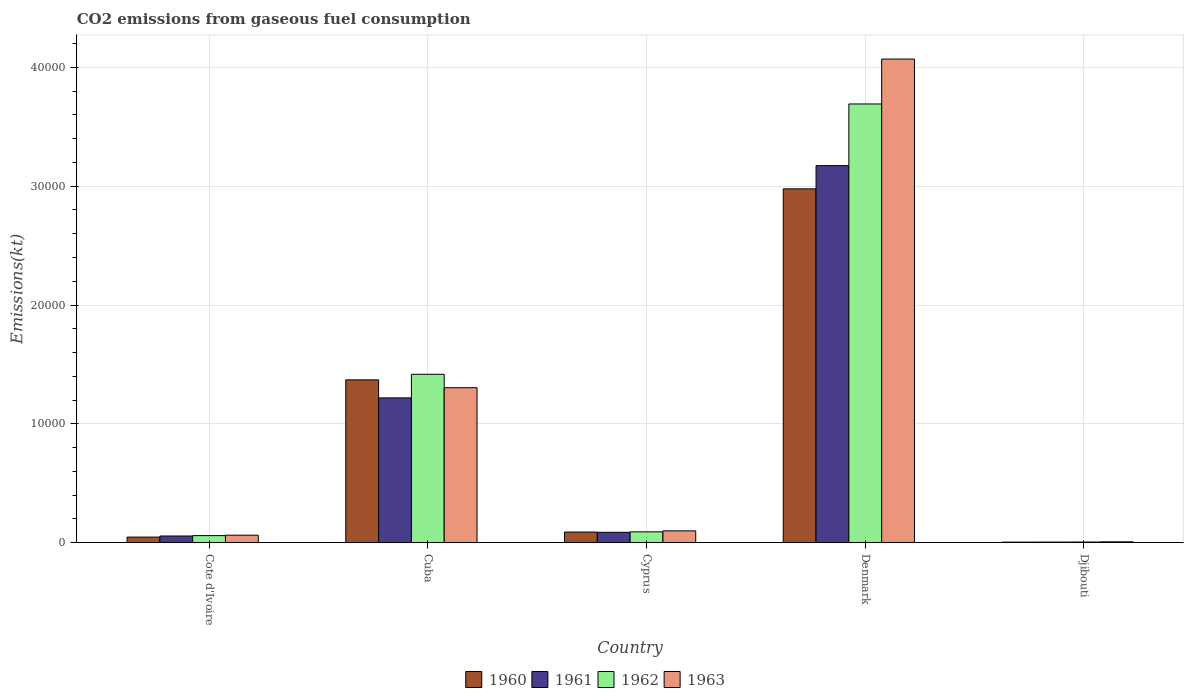How many bars are there on the 4th tick from the left?
Your answer should be compact. 4. What is the label of the 4th group of bars from the left?
Your answer should be very brief. Denmark. What is the amount of CO2 emitted in 1963 in Cote d'Ivoire?
Give a very brief answer. 623.39. Across all countries, what is the maximum amount of CO2 emitted in 1961?
Your answer should be very brief. 3.17e+04. Across all countries, what is the minimum amount of CO2 emitted in 1962?
Provide a short and direct response. 47.67. In which country was the amount of CO2 emitted in 1962 maximum?
Offer a very short reply. Denmark. In which country was the amount of CO2 emitted in 1963 minimum?
Give a very brief answer. Djibouti. What is the total amount of CO2 emitted in 1963 in the graph?
Offer a very short reply. 5.54e+04. What is the difference between the amount of CO2 emitted in 1961 in Cote d'Ivoire and that in Denmark?
Ensure brevity in your answer.  -3.12e+04. What is the difference between the amount of CO2 emitted in 1962 in Djibouti and the amount of CO2 emitted in 1963 in Denmark?
Provide a short and direct response. -4.07e+04. What is the average amount of CO2 emitted in 1961 per country?
Keep it short and to the point. 9075.83. What is the difference between the amount of CO2 emitted of/in 1963 and amount of CO2 emitted of/in 1961 in Denmark?
Provide a short and direct response. 8973.15. In how many countries, is the amount of CO2 emitted in 1962 greater than 28000 kt?
Make the answer very short. 1. What is the ratio of the amount of CO2 emitted in 1962 in Cuba to that in Cyprus?
Your response must be concise. 15.64. Is the amount of CO2 emitted in 1962 in Cuba less than that in Cyprus?
Keep it short and to the point. No. Is the difference between the amount of CO2 emitted in 1963 in Denmark and Djibouti greater than the difference between the amount of CO2 emitted in 1961 in Denmark and Djibouti?
Your answer should be compact. Yes. What is the difference between the highest and the second highest amount of CO2 emitted in 1960?
Provide a short and direct response. 1.61e+04. What is the difference between the highest and the lowest amount of CO2 emitted in 1961?
Offer a terse response. 3.17e+04. In how many countries, is the amount of CO2 emitted in 1962 greater than the average amount of CO2 emitted in 1962 taken over all countries?
Your response must be concise. 2. What does the 2nd bar from the left in Cyprus represents?
Keep it short and to the point. 1961. Is it the case that in every country, the sum of the amount of CO2 emitted in 1960 and amount of CO2 emitted in 1961 is greater than the amount of CO2 emitted in 1963?
Offer a very short reply. Yes. Does the graph contain any zero values?
Your response must be concise. No. Where does the legend appear in the graph?
Your answer should be very brief. Bottom center. How many legend labels are there?
Keep it short and to the point. 4. How are the legend labels stacked?
Provide a short and direct response. Horizontal. What is the title of the graph?
Offer a terse response. CO2 emissions from gaseous fuel consumption. What is the label or title of the Y-axis?
Offer a terse response. Emissions(kt). What is the Emissions(kt) of 1960 in Cote d'Ivoire?
Make the answer very short. 462.04. What is the Emissions(kt) of 1961 in Cote d'Ivoire?
Your response must be concise. 553.72. What is the Emissions(kt) of 1962 in Cote d'Ivoire?
Your answer should be very brief. 586.72. What is the Emissions(kt) in 1963 in Cote d'Ivoire?
Provide a succinct answer. 623.39. What is the Emissions(kt) of 1960 in Cuba?
Offer a terse response. 1.37e+04. What is the Emissions(kt) of 1961 in Cuba?
Provide a short and direct response. 1.22e+04. What is the Emissions(kt) of 1962 in Cuba?
Make the answer very short. 1.42e+04. What is the Emissions(kt) in 1963 in Cuba?
Your response must be concise. 1.30e+04. What is the Emissions(kt) in 1960 in Cyprus?
Make the answer very short. 887.41. What is the Emissions(kt) in 1961 in Cyprus?
Your answer should be very brief. 865.41. What is the Emissions(kt) in 1962 in Cyprus?
Your response must be concise. 905.75. What is the Emissions(kt) of 1963 in Cyprus?
Make the answer very short. 986.42. What is the Emissions(kt) of 1960 in Denmark?
Offer a very short reply. 2.98e+04. What is the Emissions(kt) in 1961 in Denmark?
Offer a terse response. 3.17e+04. What is the Emissions(kt) of 1962 in Denmark?
Your answer should be very brief. 3.69e+04. What is the Emissions(kt) of 1963 in Denmark?
Give a very brief answer. 4.07e+04. What is the Emissions(kt) in 1960 in Djibouti?
Offer a terse response. 40.34. What is the Emissions(kt) in 1961 in Djibouti?
Your answer should be compact. 44. What is the Emissions(kt) in 1962 in Djibouti?
Ensure brevity in your answer.  47.67. What is the Emissions(kt) of 1963 in Djibouti?
Your response must be concise. 66.01. Across all countries, what is the maximum Emissions(kt) in 1960?
Provide a short and direct response. 2.98e+04. Across all countries, what is the maximum Emissions(kt) of 1961?
Keep it short and to the point. 3.17e+04. Across all countries, what is the maximum Emissions(kt) in 1962?
Make the answer very short. 3.69e+04. Across all countries, what is the maximum Emissions(kt) of 1963?
Provide a succinct answer. 4.07e+04. Across all countries, what is the minimum Emissions(kt) in 1960?
Make the answer very short. 40.34. Across all countries, what is the minimum Emissions(kt) in 1961?
Offer a very short reply. 44. Across all countries, what is the minimum Emissions(kt) of 1962?
Provide a succinct answer. 47.67. Across all countries, what is the minimum Emissions(kt) in 1963?
Your answer should be compact. 66.01. What is the total Emissions(kt) of 1960 in the graph?
Your answer should be very brief. 4.49e+04. What is the total Emissions(kt) in 1961 in the graph?
Provide a short and direct response. 4.54e+04. What is the total Emissions(kt) of 1962 in the graph?
Make the answer very short. 5.26e+04. What is the total Emissions(kt) in 1963 in the graph?
Provide a short and direct response. 5.54e+04. What is the difference between the Emissions(kt) of 1960 in Cote d'Ivoire and that in Cuba?
Keep it short and to the point. -1.32e+04. What is the difference between the Emissions(kt) in 1961 in Cote d'Ivoire and that in Cuba?
Provide a succinct answer. -1.16e+04. What is the difference between the Emissions(kt) of 1962 in Cote d'Ivoire and that in Cuba?
Provide a succinct answer. -1.36e+04. What is the difference between the Emissions(kt) in 1963 in Cote d'Ivoire and that in Cuba?
Give a very brief answer. -1.24e+04. What is the difference between the Emissions(kt) in 1960 in Cote d'Ivoire and that in Cyprus?
Ensure brevity in your answer.  -425.37. What is the difference between the Emissions(kt) of 1961 in Cote d'Ivoire and that in Cyprus?
Keep it short and to the point. -311.69. What is the difference between the Emissions(kt) in 1962 in Cote d'Ivoire and that in Cyprus?
Offer a terse response. -319.03. What is the difference between the Emissions(kt) in 1963 in Cote d'Ivoire and that in Cyprus?
Your answer should be very brief. -363.03. What is the difference between the Emissions(kt) of 1960 in Cote d'Ivoire and that in Denmark?
Provide a succinct answer. -2.93e+04. What is the difference between the Emissions(kt) of 1961 in Cote d'Ivoire and that in Denmark?
Give a very brief answer. -3.12e+04. What is the difference between the Emissions(kt) of 1962 in Cote d'Ivoire and that in Denmark?
Ensure brevity in your answer.  -3.63e+04. What is the difference between the Emissions(kt) of 1963 in Cote d'Ivoire and that in Denmark?
Keep it short and to the point. -4.01e+04. What is the difference between the Emissions(kt) in 1960 in Cote d'Ivoire and that in Djibouti?
Your response must be concise. 421.7. What is the difference between the Emissions(kt) in 1961 in Cote d'Ivoire and that in Djibouti?
Offer a terse response. 509.71. What is the difference between the Emissions(kt) of 1962 in Cote d'Ivoire and that in Djibouti?
Provide a short and direct response. 539.05. What is the difference between the Emissions(kt) in 1963 in Cote d'Ivoire and that in Djibouti?
Keep it short and to the point. 557.38. What is the difference between the Emissions(kt) in 1960 in Cuba and that in Cyprus?
Your response must be concise. 1.28e+04. What is the difference between the Emissions(kt) in 1961 in Cuba and that in Cyprus?
Provide a short and direct response. 1.13e+04. What is the difference between the Emissions(kt) in 1962 in Cuba and that in Cyprus?
Keep it short and to the point. 1.33e+04. What is the difference between the Emissions(kt) of 1963 in Cuba and that in Cyprus?
Ensure brevity in your answer.  1.21e+04. What is the difference between the Emissions(kt) in 1960 in Cuba and that in Denmark?
Keep it short and to the point. -1.61e+04. What is the difference between the Emissions(kt) in 1961 in Cuba and that in Denmark?
Your answer should be compact. -1.96e+04. What is the difference between the Emissions(kt) of 1962 in Cuba and that in Denmark?
Your answer should be compact. -2.28e+04. What is the difference between the Emissions(kt) of 1963 in Cuba and that in Denmark?
Your answer should be very brief. -2.77e+04. What is the difference between the Emissions(kt) of 1960 in Cuba and that in Djibouti?
Your response must be concise. 1.37e+04. What is the difference between the Emissions(kt) of 1961 in Cuba and that in Djibouti?
Your response must be concise. 1.21e+04. What is the difference between the Emissions(kt) of 1962 in Cuba and that in Djibouti?
Keep it short and to the point. 1.41e+04. What is the difference between the Emissions(kt) in 1963 in Cuba and that in Djibouti?
Offer a terse response. 1.30e+04. What is the difference between the Emissions(kt) in 1960 in Cyprus and that in Denmark?
Offer a terse response. -2.89e+04. What is the difference between the Emissions(kt) of 1961 in Cyprus and that in Denmark?
Your answer should be very brief. -3.09e+04. What is the difference between the Emissions(kt) of 1962 in Cyprus and that in Denmark?
Provide a short and direct response. -3.60e+04. What is the difference between the Emissions(kt) in 1963 in Cyprus and that in Denmark?
Offer a terse response. -3.97e+04. What is the difference between the Emissions(kt) in 1960 in Cyprus and that in Djibouti?
Provide a succinct answer. 847.08. What is the difference between the Emissions(kt) in 1961 in Cyprus and that in Djibouti?
Your answer should be very brief. 821.41. What is the difference between the Emissions(kt) in 1962 in Cyprus and that in Djibouti?
Give a very brief answer. 858.08. What is the difference between the Emissions(kt) in 1963 in Cyprus and that in Djibouti?
Your answer should be compact. 920.42. What is the difference between the Emissions(kt) of 1960 in Denmark and that in Djibouti?
Make the answer very short. 2.97e+04. What is the difference between the Emissions(kt) of 1961 in Denmark and that in Djibouti?
Offer a terse response. 3.17e+04. What is the difference between the Emissions(kt) in 1962 in Denmark and that in Djibouti?
Provide a short and direct response. 3.69e+04. What is the difference between the Emissions(kt) in 1963 in Denmark and that in Djibouti?
Your answer should be very brief. 4.06e+04. What is the difference between the Emissions(kt) in 1960 in Cote d'Ivoire and the Emissions(kt) in 1961 in Cuba?
Provide a succinct answer. -1.17e+04. What is the difference between the Emissions(kt) of 1960 in Cote d'Ivoire and the Emissions(kt) of 1962 in Cuba?
Your response must be concise. -1.37e+04. What is the difference between the Emissions(kt) in 1960 in Cote d'Ivoire and the Emissions(kt) in 1963 in Cuba?
Your answer should be very brief. -1.26e+04. What is the difference between the Emissions(kt) in 1961 in Cote d'Ivoire and the Emissions(kt) in 1962 in Cuba?
Your response must be concise. -1.36e+04. What is the difference between the Emissions(kt) in 1961 in Cote d'Ivoire and the Emissions(kt) in 1963 in Cuba?
Keep it short and to the point. -1.25e+04. What is the difference between the Emissions(kt) in 1962 in Cote d'Ivoire and the Emissions(kt) in 1963 in Cuba?
Provide a succinct answer. -1.25e+04. What is the difference between the Emissions(kt) of 1960 in Cote d'Ivoire and the Emissions(kt) of 1961 in Cyprus?
Your answer should be very brief. -403.37. What is the difference between the Emissions(kt) of 1960 in Cote d'Ivoire and the Emissions(kt) of 1962 in Cyprus?
Keep it short and to the point. -443.71. What is the difference between the Emissions(kt) of 1960 in Cote d'Ivoire and the Emissions(kt) of 1963 in Cyprus?
Offer a very short reply. -524.38. What is the difference between the Emissions(kt) in 1961 in Cote d'Ivoire and the Emissions(kt) in 1962 in Cyprus?
Make the answer very short. -352.03. What is the difference between the Emissions(kt) in 1961 in Cote d'Ivoire and the Emissions(kt) in 1963 in Cyprus?
Provide a short and direct response. -432.71. What is the difference between the Emissions(kt) in 1962 in Cote d'Ivoire and the Emissions(kt) in 1963 in Cyprus?
Provide a succinct answer. -399.7. What is the difference between the Emissions(kt) in 1960 in Cote d'Ivoire and the Emissions(kt) in 1961 in Denmark?
Make the answer very short. -3.13e+04. What is the difference between the Emissions(kt) of 1960 in Cote d'Ivoire and the Emissions(kt) of 1962 in Denmark?
Make the answer very short. -3.65e+04. What is the difference between the Emissions(kt) in 1960 in Cote d'Ivoire and the Emissions(kt) in 1963 in Denmark?
Offer a very short reply. -4.02e+04. What is the difference between the Emissions(kt) of 1961 in Cote d'Ivoire and the Emissions(kt) of 1962 in Denmark?
Give a very brief answer. -3.64e+04. What is the difference between the Emissions(kt) of 1961 in Cote d'Ivoire and the Emissions(kt) of 1963 in Denmark?
Ensure brevity in your answer.  -4.02e+04. What is the difference between the Emissions(kt) in 1962 in Cote d'Ivoire and the Emissions(kt) in 1963 in Denmark?
Your response must be concise. -4.01e+04. What is the difference between the Emissions(kt) of 1960 in Cote d'Ivoire and the Emissions(kt) of 1961 in Djibouti?
Your answer should be very brief. 418.04. What is the difference between the Emissions(kt) in 1960 in Cote d'Ivoire and the Emissions(kt) in 1962 in Djibouti?
Your response must be concise. 414.37. What is the difference between the Emissions(kt) of 1960 in Cote d'Ivoire and the Emissions(kt) of 1963 in Djibouti?
Provide a short and direct response. 396.04. What is the difference between the Emissions(kt) of 1961 in Cote d'Ivoire and the Emissions(kt) of 1962 in Djibouti?
Keep it short and to the point. 506.05. What is the difference between the Emissions(kt) in 1961 in Cote d'Ivoire and the Emissions(kt) in 1963 in Djibouti?
Provide a succinct answer. 487.71. What is the difference between the Emissions(kt) of 1962 in Cote d'Ivoire and the Emissions(kt) of 1963 in Djibouti?
Your answer should be very brief. 520.71. What is the difference between the Emissions(kt) of 1960 in Cuba and the Emissions(kt) of 1961 in Cyprus?
Offer a terse response. 1.28e+04. What is the difference between the Emissions(kt) of 1960 in Cuba and the Emissions(kt) of 1962 in Cyprus?
Offer a terse response. 1.28e+04. What is the difference between the Emissions(kt) in 1960 in Cuba and the Emissions(kt) in 1963 in Cyprus?
Provide a short and direct response. 1.27e+04. What is the difference between the Emissions(kt) in 1961 in Cuba and the Emissions(kt) in 1962 in Cyprus?
Ensure brevity in your answer.  1.13e+04. What is the difference between the Emissions(kt) of 1961 in Cuba and the Emissions(kt) of 1963 in Cyprus?
Keep it short and to the point. 1.12e+04. What is the difference between the Emissions(kt) of 1962 in Cuba and the Emissions(kt) of 1963 in Cyprus?
Offer a very short reply. 1.32e+04. What is the difference between the Emissions(kt) of 1960 in Cuba and the Emissions(kt) of 1961 in Denmark?
Provide a succinct answer. -1.80e+04. What is the difference between the Emissions(kt) of 1960 in Cuba and the Emissions(kt) of 1962 in Denmark?
Offer a very short reply. -2.32e+04. What is the difference between the Emissions(kt) of 1960 in Cuba and the Emissions(kt) of 1963 in Denmark?
Ensure brevity in your answer.  -2.70e+04. What is the difference between the Emissions(kt) of 1961 in Cuba and the Emissions(kt) of 1962 in Denmark?
Provide a short and direct response. -2.47e+04. What is the difference between the Emissions(kt) in 1961 in Cuba and the Emissions(kt) in 1963 in Denmark?
Ensure brevity in your answer.  -2.85e+04. What is the difference between the Emissions(kt) of 1962 in Cuba and the Emissions(kt) of 1963 in Denmark?
Your response must be concise. -2.65e+04. What is the difference between the Emissions(kt) of 1960 in Cuba and the Emissions(kt) of 1961 in Djibouti?
Your response must be concise. 1.37e+04. What is the difference between the Emissions(kt) of 1960 in Cuba and the Emissions(kt) of 1962 in Djibouti?
Offer a very short reply. 1.37e+04. What is the difference between the Emissions(kt) of 1960 in Cuba and the Emissions(kt) of 1963 in Djibouti?
Ensure brevity in your answer.  1.36e+04. What is the difference between the Emissions(kt) in 1961 in Cuba and the Emissions(kt) in 1962 in Djibouti?
Offer a terse response. 1.21e+04. What is the difference between the Emissions(kt) of 1961 in Cuba and the Emissions(kt) of 1963 in Djibouti?
Offer a terse response. 1.21e+04. What is the difference between the Emissions(kt) in 1962 in Cuba and the Emissions(kt) in 1963 in Djibouti?
Offer a terse response. 1.41e+04. What is the difference between the Emissions(kt) of 1960 in Cyprus and the Emissions(kt) of 1961 in Denmark?
Ensure brevity in your answer.  -3.08e+04. What is the difference between the Emissions(kt) in 1960 in Cyprus and the Emissions(kt) in 1962 in Denmark?
Provide a succinct answer. -3.60e+04. What is the difference between the Emissions(kt) in 1960 in Cyprus and the Emissions(kt) in 1963 in Denmark?
Give a very brief answer. -3.98e+04. What is the difference between the Emissions(kt) of 1961 in Cyprus and the Emissions(kt) of 1962 in Denmark?
Ensure brevity in your answer.  -3.61e+04. What is the difference between the Emissions(kt) of 1961 in Cyprus and the Emissions(kt) of 1963 in Denmark?
Ensure brevity in your answer.  -3.98e+04. What is the difference between the Emissions(kt) of 1962 in Cyprus and the Emissions(kt) of 1963 in Denmark?
Keep it short and to the point. -3.98e+04. What is the difference between the Emissions(kt) in 1960 in Cyprus and the Emissions(kt) in 1961 in Djibouti?
Your answer should be compact. 843.41. What is the difference between the Emissions(kt) in 1960 in Cyprus and the Emissions(kt) in 1962 in Djibouti?
Offer a terse response. 839.74. What is the difference between the Emissions(kt) of 1960 in Cyprus and the Emissions(kt) of 1963 in Djibouti?
Your response must be concise. 821.41. What is the difference between the Emissions(kt) of 1961 in Cyprus and the Emissions(kt) of 1962 in Djibouti?
Keep it short and to the point. 817.74. What is the difference between the Emissions(kt) of 1961 in Cyprus and the Emissions(kt) of 1963 in Djibouti?
Offer a terse response. 799.41. What is the difference between the Emissions(kt) of 1962 in Cyprus and the Emissions(kt) of 1963 in Djibouti?
Provide a short and direct response. 839.74. What is the difference between the Emissions(kt) in 1960 in Denmark and the Emissions(kt) in 1961 in Djibouti?
Keep it short and to the point. 2.97e+04. What is the difference between the Emissions(kt) of 1960 in Denmark and the Emissions(kt) of 1962 in Djibouti?
Your answer should be compact. 2.97e+04. What is the difference between the Emissions(kt) in 1960 in Denmark and the Emissions(kt) in 1963 in Djibouti?
Keep it short and to the point. 2.97e+04. What is the difference between the Emissions(kt) of 1961 in Denmark and the Emissions(kt) of 1962 in Djibouti?
Ensure brevity in your answer.  3.17e+04. What is the difference between the Emissions(kt) in 1961 in Denmark and the Emissions(kt) in 1963 in Djibouti?
Offer a terse response. 3.17e+04. What is the difference between the Emissions(kt) in 1962 in Denmark and the Emissions(kt) in 1963 in Djibouti?
Offer a very short reply. 3.69e+04. What is the average Emissions(kt) in 1960 per country?
Offer a terse response. 8973.88. What is the average Emissions(kt) of 1961 per country?
Your answer should be compact. 9075.83. What is the average Emissions(kt) of 1962 per country?
Your answer should be compact. 1.05e+04. What is the average Emissions(kt) of 1963 per country?
Offer a terse response. 1.11e+04. What is the difference between the Emissions(kt) of 1960 and Emissions(kt) of 1961 in Cote d'Ivoire?
Offer a very short reply. -91.67. What is the difference between the Emissions(kt) in 1960 and Emissions(kt) in 1962 in Cote d'Ivoire?
Give a very brief answer. -124.68. What is the difference between the Emissions(kt) in 1960 and Emissions(kt) in 1963 in Cote d'Ivoire?
Your response must be concise. -161.35. What is the difference between the Emissions(kt) in 1961 and Emissions(kt) in 1962 in Cote d'Ivoire?
Provide a succinct answer. -33. What is the difference between the Emissions(kt) of 1961 and Emissions(kt) of 1963 in Cote d'Ivoire?
Your answer should be very brief. -69.67. What is the difference between the Emissions(kt) in 1962 and Emissions(kt) in 1963 in Cote d'Ivoire?
Provide a short and direct response. -36.67. What is the difference between the Emissions(kt) in 1960 and Emissions(kt) in 1961 in Cuba?
Provide a succinct answer. 1518.14. What is the difference between the Emissions(kt) of 1960 and Emissions(kt) of 1962 in Cuba?
Your response must be concise. -469.38. What is the difference between the Emissions(kt) of 1960 and Emissions(kt) of 1963 in Cuba?
Your answer should be very brief. 660.06. What is the difference between the Emissions(kt) in 1961 and Emissions(kt) in 1962 in Cuba?
Provide a succinct answer. -1987.51. What is the difference between the Emissions(kt) of 1961 and Emissions(kt) of 1963 in Cuba?
Make the answer very short. -858.08. What is the difference between the Emissions(kt) of 1962 and Emissions(kt) of 1963 in Cuba?
Ensure brevity in your answer.  1129.44. What is the difference between the Emissions(kt) in 1960 and Emissions(kt) in 1961 in Cyprus?
Make the answer very short. 22. What is the difference between the Emissions(kt) in 1960 and Emissions(kt) in 1962 in Cyprus?
Offer a very short reply. -18.34. What is the difference between the Emissions(kt) of 1960 and Emissions(kt) of 1963 in Cyprus?
Your answer should be very brief. -99.01. What is the difference between the Emissions(kt) in 1961 and Emissions(kt) in 1962 in Cyprus?
Your answer should be very brief. -40.34. What is the difference between the Emissions(kt) of 1961 and Emissions(kt) of 1963 in Cyprus?
Your response must be concise. -121.01. What is the difference between the Emissions(kt) of 1962 and Emissions(kt) of 1963 in Cyprus?
Your answer should be compact. -80.67. What is the difference between the Emissions(kt) of 1960 and Emissions(kt) of 1961 in Denmark?
Your response must be concise. -1954.51. What is the difference between the Emissions(kt) in 1960 and Emissions(kt) in 1962 in Denmark?
Your response must be concise. -7146.98. What is the difference between the Emissions(kt) of 1960 and Emissions(kt) of 1963 in Denmark?
Ensure brevity in your answer.  -1.09e+04. What is the difference between the Emissions(kt) of 1961 and Emissions(kt) of 1962 in Denmark?
Provide a short and direct response. -5192.47. What is the difference between the Emissions(kt) of 1961 and Emissions(kt) of 1963 in Denmark?
Give a very brief answer. -8973.15. What is the difference between the Emissions(kt) in 1962 and Emissions(kt) in 1963 in Denmark?
Keep it short and to the point. -3780.68. What is the difference between the Emissions(kt) in 1960 and Emissions(kt) in 1961 in Djibouti?
Your answer should be compact. -3.67. What is the difference between the Emissions(kt) of 1960 and Emissions(kt) of 1962 in Djibouti?
Provide a succinct answer. -7.33. What is the difference between the Emissions(kt) in 1960 and Emissions(kt) in 1963 in Djibouti?
Provide a short and direct response. -25.67. What is the difference between the Emissions(kt) in 1961 and Emissions(kt) in 1962 in Djibouti?
Your answer should be very brief. -3.67. What is the difference between the Emissions(kt) in 1961 and Emissions(kt) in 1963 in Djibouti?
Your answer should be very brief. -22. What is the difference between the Emissions(kt) of 1962 and Emissions(kt) of 1963 in Djibouti?
Give a very brief answer. -18.34. What is the ratio of the Emissions(kt) of 1960 in Cote d'Ivoire to that in Cuba?
Keep it short and to the point. 0.03. What is the ratio of the Emissions(kt) in 1961 in Cote d'Ivoire to that in Cuba?
Your response must be concise. 0.05. What is the ratio of the Emissions(kt) in 1962 in Cote d'Ivoire to that in Cuba?
Ensure brevity in your answer.  0.04. What is the ratio of the Emissions(kt) of 1963 in Cote d'Ivoire to that in Cuba?
Provide a short and direct response. 0.05. What is the ratio of the Emissions(kt) in 1960 in Cote d'Ivoire to that in Cyprus?
Your answer should be very brief. 0.52. What is the ratio of the Emissions(kt) in 1961 in Cote d'Ivoire to that in Cyprus?
Make the answer very short. 0.64. What is the ratio of the Emissions(kt) in 1962 in Cote d'Ivoire to that in Cyprus?
Make the answer very short. 0.65. What is the ratio of the Emissions(kt) of 1963 in Cote d'Ivoire to that in Cyprus?
Your answer should be compact. 0.63. What is the ratio of the Emissions(kt) of 1960 in Cote d'Ivoire to that in Denmark?
Your response must be concise. 0.02. What is the ratio of the Emissions(kt) in 1961 in Cote d'Ivoire to that in Denmark?
Ensure brevity in your answer.  0.02. What is the ratio of the Emissions(kt) of 1962 in Cote d'Ivoire to that in Denmark?
Keep it short and to the point. 0.02. What is the ratio of the Emissions(kt) of 1963 in Cote d'Ivoire to that in Denmark?
Provide a short and direct response. 0.02. What is the ratio of the Emissions(kt) in 1960 in Cote d'Ivoire to that in Djibouti?
Your answer should be compact. 11.45. What is the ratio of the Emissions(kt) in 1961 in Cote d'Ivoire to that in Djibouti?
Keep it short and to the point. 12.58. What is the ratio of the Emissions(kt) of 1962 in Cote d'Ivoire to that in Djibouti?
Offer a very short reply. 12.31. What is the ratio of the Emissions(kt) in 1963 in Cote d'Ivoire to that in Djibouti?
Provide a short and direct response. 9.44. What is the ratio of the Emissions(kt) in 1960 in Cuba to that in Cyprus?
Make the answer very short. 15.44. What is the ratio of the Emissions(kt) of 1961 in Cuba to that in Cyprus?
Give a very brief answer. 14.08. What is the ratio of the Emissions(kt) of 1962 in Cuba to that in Cyprus?
Your response must be concise. 15.64. What is the ratio of the Emissions(kt) in 1963 in Cuba to that in Cyprus?
Offer a very short reply. 13.22. What is the ratio of the Emissions(kt) of 1960 in Cuba to that in Denmark?
Provide a succinct answer. 0.46. What is the ratio of the Emissions(kt) of 1961 in Cuba to that in Denmark?
Make the answer very short. 0.38. What is the ratio of the Emissions(kt) in 1962 in Cuba to that in Denmark?
Ensure brevity in your answer.  0.38. What is the ratio of the Emissions(kt) of 1963 in Cuba to that in Denmark?
Your answer should be compact. 0.32. What is the ratio of the Emissions(kt) of 1960 in Cuba to that in Djibouti?
Keep it short and to the point. 339.64. What is the ratio of the Emissions(kt) of 1961 in Cuba to that in Djibouti?
Keep it short and to the point. 276.83. What is the ratio of the Emissions(kt) in 1962 in Cuba to that in Djibouti?
Your answer should be very brief. 297.23. What is the ratio of the Emissions(kt) of 1963 in Cuba to that in Djibouti?
Give a very brief answer. 197.56. What is the ratio of the Emissions(kt) of 1960 in Cyprus to that in Denmark?
Ensure brevity in your answer.  0.03. What is the ratio of the Emissions(kt) in 1961 in Cyprus to that in Denmark?
Your answer should be compact. 0.03. What is the ratio of the Emissions(kt) of 1962 in Cyprus to that in Denmark?
Offer a terse response. 0.02. What is the ratio of the Emissions(kt) in 1963 in Cyprus to that in Denmark?
Offer a terse response. 0.02. What is the ratio of the Emissions(kt) in 1960 in Cyprus to that in Djibouti?
Your response must be concise. 22. What is the ratio of the Emissions(kt) of 1961 in Cyprus to that in Djibouti?
Keep it short and to the point. 19.67. What is the ratio of the Emissions(kt) of 1962 in Cyprus to that in Djibouti?
Offer a terse response. 19. What is the ratio of the Emissions(kt) in 1963 in Cyprus to that in Djibouti?
Ensure brevity in your answer.  14.94. What is the ratio of the Emissions(kt) of 1960 in Denmark to that in Djibouti?
Provide a succinct answer. 738.27. What is the ratio of the Emissions(kt) in 1961 in Denmark to that in Djibouti?
Give a very brief answer. 721.17. What is the ratio of the Emissions(kt) of 1962 in Denmark to that in Djibouti?
Your answer should be compact. 774.62. What is the ratio of the Emissions(kt) of 1963 in Denmark to that in Djibouti?
Ensure brevity in your answer.  616.72. What is the difference between the highest and the second highest Emissions(kt) in 1960?
Make the answer very short. 1.61e+04. What is the difference between the highest and the second highest Emissions(kt) of 1961?
Keep it short and to the point. 1.96e+04. What is the difference between the highest and the second highest Emissions(kt) in 1962?
Provide a succinct answer. 2.28e+04. What is the difference between the highest and the second highest Emissions(kt) in 1963?
Keep it short and to the point. 2.77e+04. What is the difference between the highest and the lowest Emissions(kt) of 1960?
Provide a short and direct response. 2.97e+04. What is the difference between the highest and the lowest Emissions(kt) of 1961?
Keep it short and to the point. 3.17e+04. What is the difference between the highest and the lowest Emissions(kt) in 1962?
Keep it short and to the point. 3.69e+04. What is the difference between the highest and the lowest Emissions(kt) of 1963?
Provide a succinct answer. 4.06e+04. 